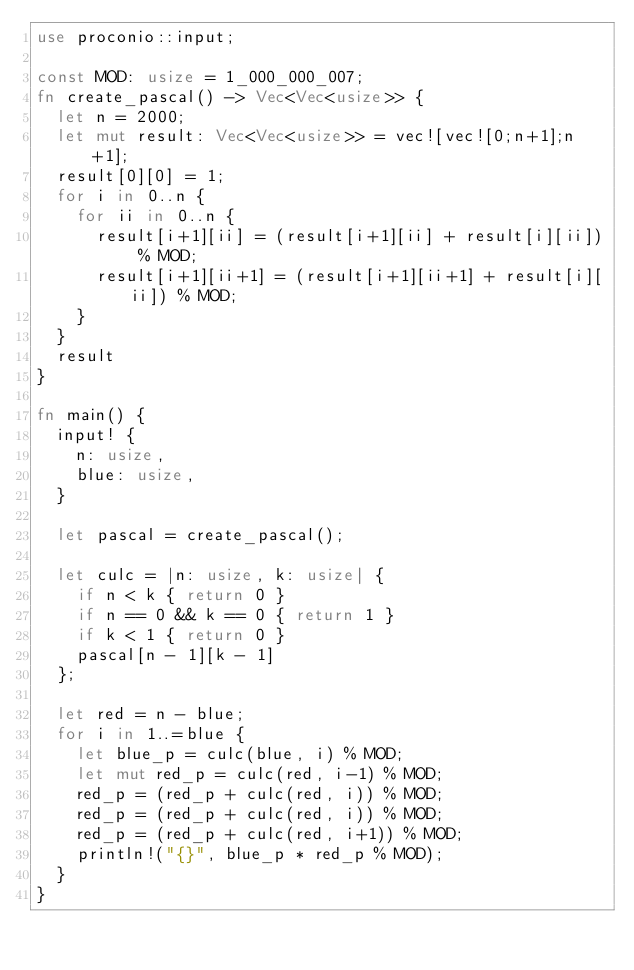<code> <loc_0><loc_0><loc_500><loc_500><_Rust_>use proconio::input;

const MOD: usize = 1_000_000_007;
fn create_pascal() -> Vec<Vec<usize>> {
  let n = 2000;
  let mut result: Vec<Vec<usize>> = vec![vec![0;n+1];n+1];
  result[0][0] = 1;
  for i in 0..n {
    for ii in 0..n {
      result[i+1][ii] = (result[i+1][ii] + result[i][ii]) % MOD;
      result[i+1][ii+1] = (result[i+1][ii+1] + result[i][ii]) % MOD;
    } 
  }
  result
}

fn main() {
  input! {
    n: usize,
    blue: usize,
  }

  let pascal = create_pascal();
  
  let culc = |n: usize, k: usize| {
    if n < k { return 0 }
    if n == 0 && k == 0 { return 1 }
    if k < 1 { return 0 }
    pascal[n - 1][k - 1]
  };
  
  let red = n - blue;
  for i in 1..=blue {
    let blue_p = culc(blue, i) % MOD;
    let mut red_p = culc(red, i-1) % MOD;
    red_p = (red_p + culc(red, i)) % MOD;
    red_p = (red_p + culc(red, i)) % MOD;
    red_p = (red_p + culc(red, i+1)) % MOD;
    println!("{}", blue_p * red_p % MOD);
  }
}</code> 